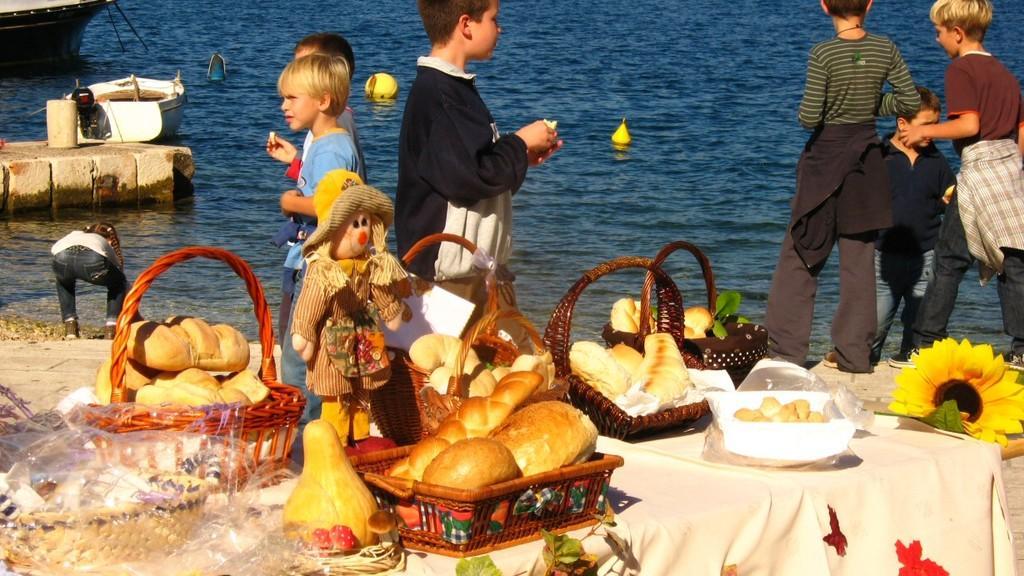Describe this image in one or two sentences. There is a table with white cloth. On the table there are baskets with beads, toy, plastic cover and many other items. Also there is a sunflower on the right side. In the back there are many children. Also there is water. And there is a boat in the water. 